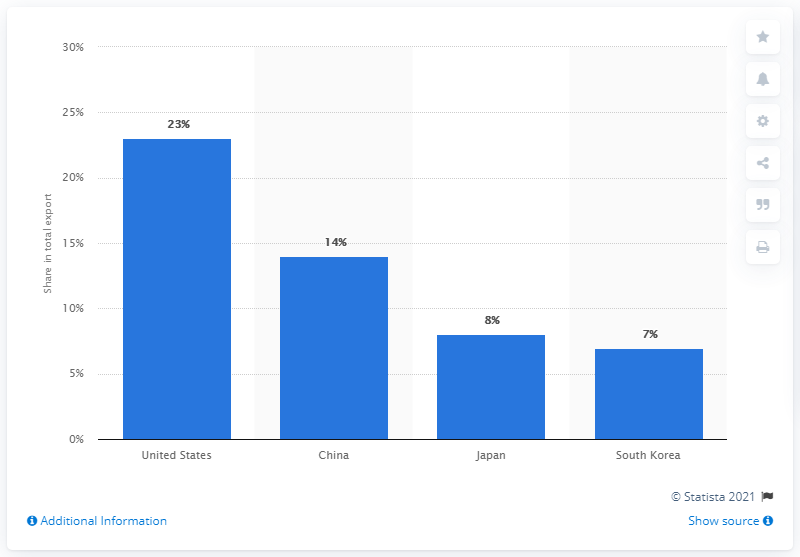List a handful of essential elements in this visual. China was responsible for 14% of the exports sent to Vietnam. China and Japan account for approximately 22% of Vietnam's total exports. 